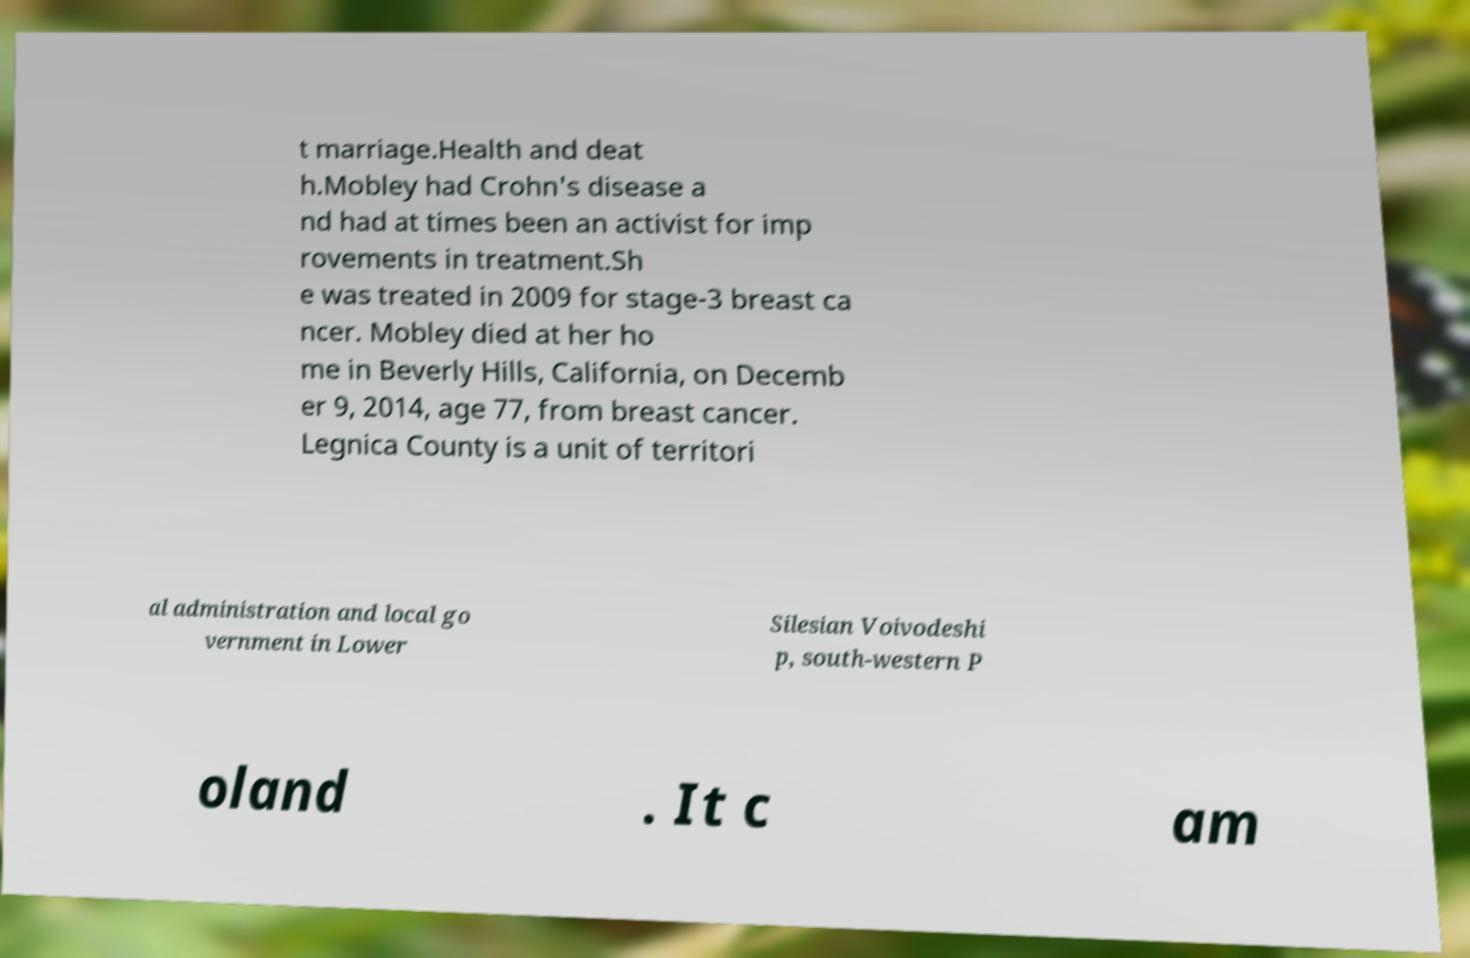I need the written content from this picture converted into text. Can you do that? t marriage.Health and deat h.Mobley had Crohn's disease a nd had at times been an activist for imp rovements in treatment.Sh e was treated in 2009 for stage-3 breast ca ncer. Mobley died at her ho me in Beverly Hills, California, on Decemb er 9, 2014, age 77, from breast cancer. Legnica County is a unit of territori al administration and local go vernment in Lower Silesian Voivodeshi p, south-western P oland . It c am 